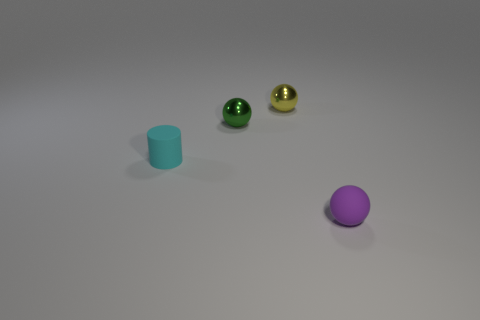There is a tiny sphere in front of the cyan rubber cylinder; how many purple objects are on the right side of it?
Your response must be concise. 0. Is the object that is right of the tiny yellow thing made of the same material as the tiny yellow object?
Ensure brevity in your answer.  No. Are there any other things that are the same material as the green ball?
Keep it short and to the point. Yes. There is a thing that is behind the tiny metal sphere to the left of the tiny yellow metallic thing; what is its size?
Give a very brief answer. Small. What size is the matte thing that is behind the small rubber thing in front of the tiny matte thing left of the matte ball?
Make the answer very short. Small. Does the tiny matte object that is behind the purple rubber thing have the same shape as the small object behind the green metallic ball?
Provide a succinct answer. No. What number of other things are there of the same color as the cylinder?
Your answer should be compact. 0. Do the thing that is in front of the cyan thing and the small cyan rubber object have the same size?
Ensure brevity in your answer.  Yes. Does the small ball to the right of the yellow ball have the same material as the sphere left of the yellow shiny ball?
Give a very brief answer. No. Is there a yellow shiny sphere of the same size as the cyan matte thing?
Your answer should be very brief. Yes. 